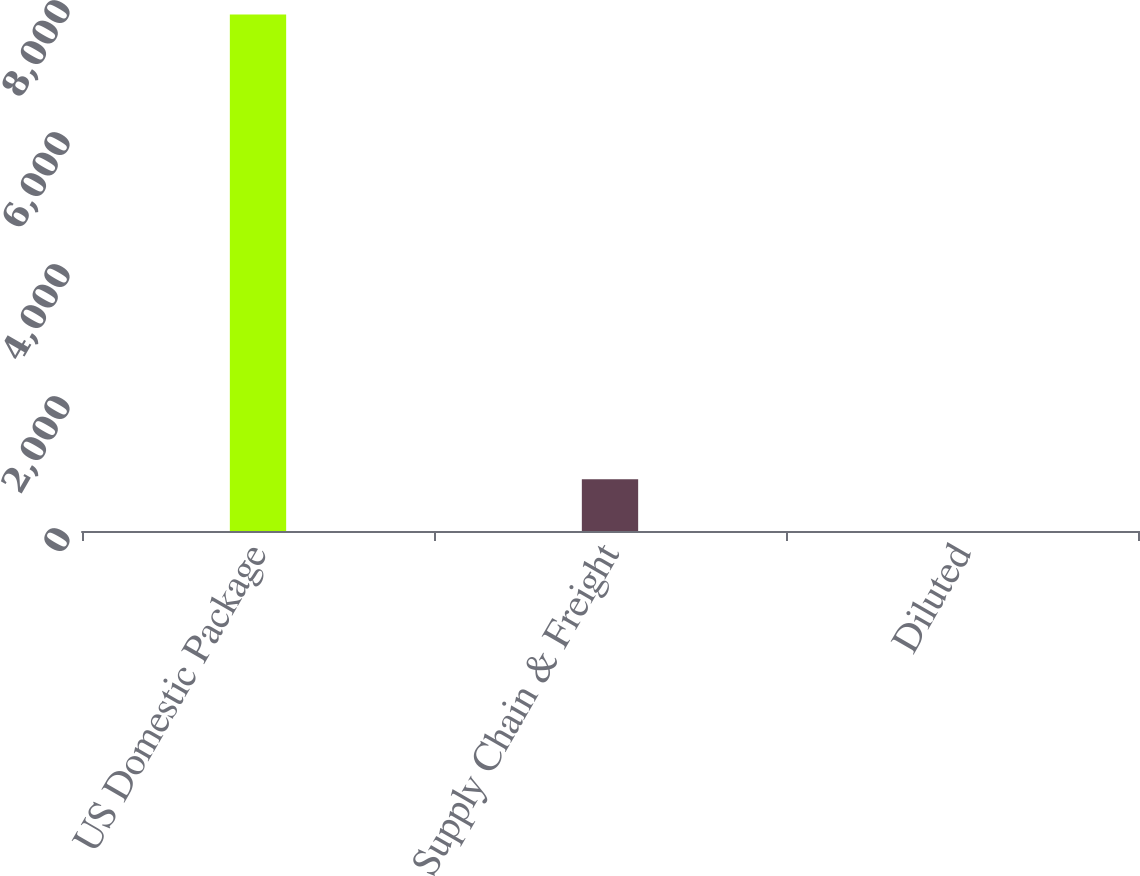<chart> <loc_0><loc_0><loc_500><loc_500><bar_chart><fcel>US Domestic Package<fcel>Supply Chain & Freight<fcel>Diluted<nl><fcel>7824<fcel>783.26<fcel>0.95<nl></chart> 